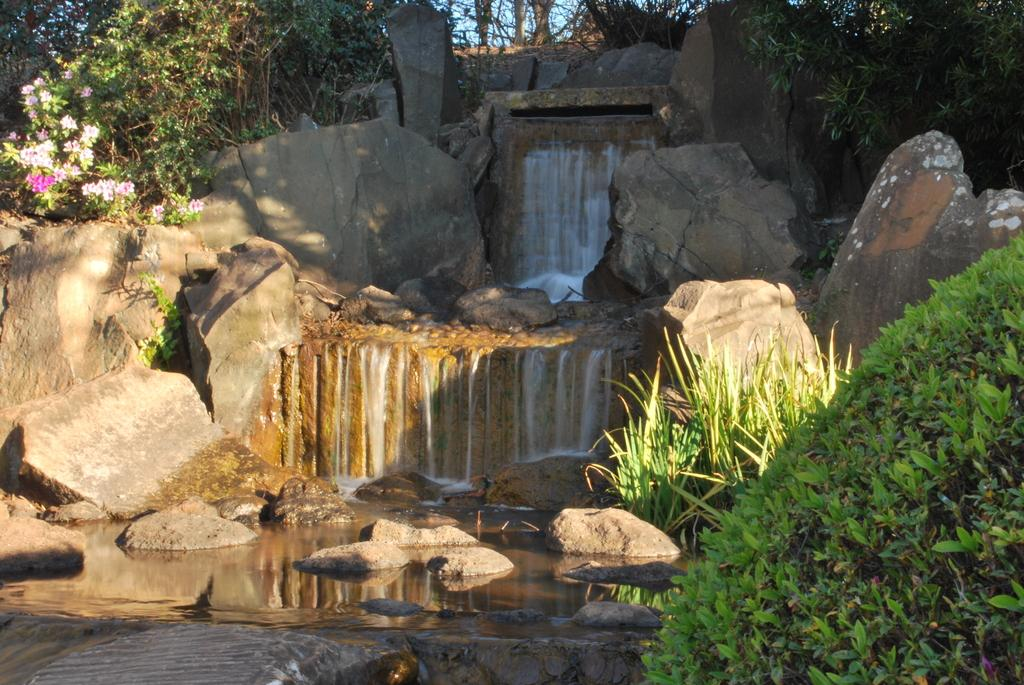What natural feature is the main subject of the image? There is a waterfall in the image. How is the water moving in the image? Water is flowing down from rocks in the image. What type of vegetation is present near the waterfall? There are plants beside the rocks in the image. What additional floral elements can be seen in the image? There are flowers in the image. What color is the balloon tied to the cat in the image? There is no balloon or cat present in the image. 